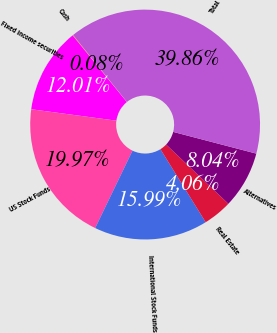Convert chart to OTSL. <chart><loc_0><loc_0><loc_500><loc_500><pie_chart><fcel>Cash<fcel>Fixed income securities<fcel>US Stock Funds<fcel>International Stock Funds<fcel>Real Estate<fcel>Alternatives<fcel>Total<nl><fcel>0.08%<fcel>12.01%<fcel>19.97%<fcel>15.99%<fcel>4.06%<fcel>8.04%<fcel>39.86%<nl></chart> 